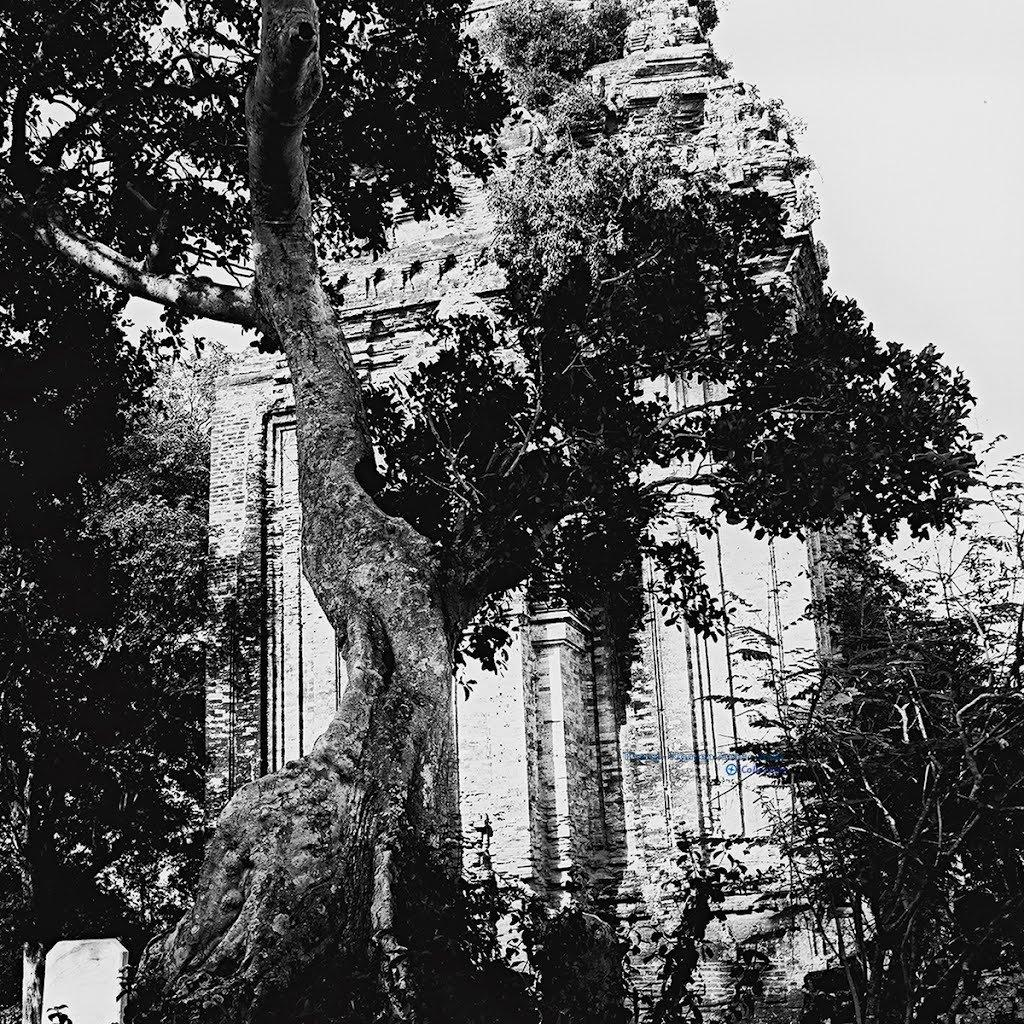What is the color scheme of the image? The image is black and white. What type of structure can be seen in the image? There is a building in the image. What type of natural elements are present in the image? There are stones and trees in the image. What can be seen in the background of the image? The sky is visible in the background of the image. Can you see any veins in the image? There are no veins present in the image, as it features a building, stones, trees, and the sky. How many casts are visible in the image? There are no casts present in the image. 